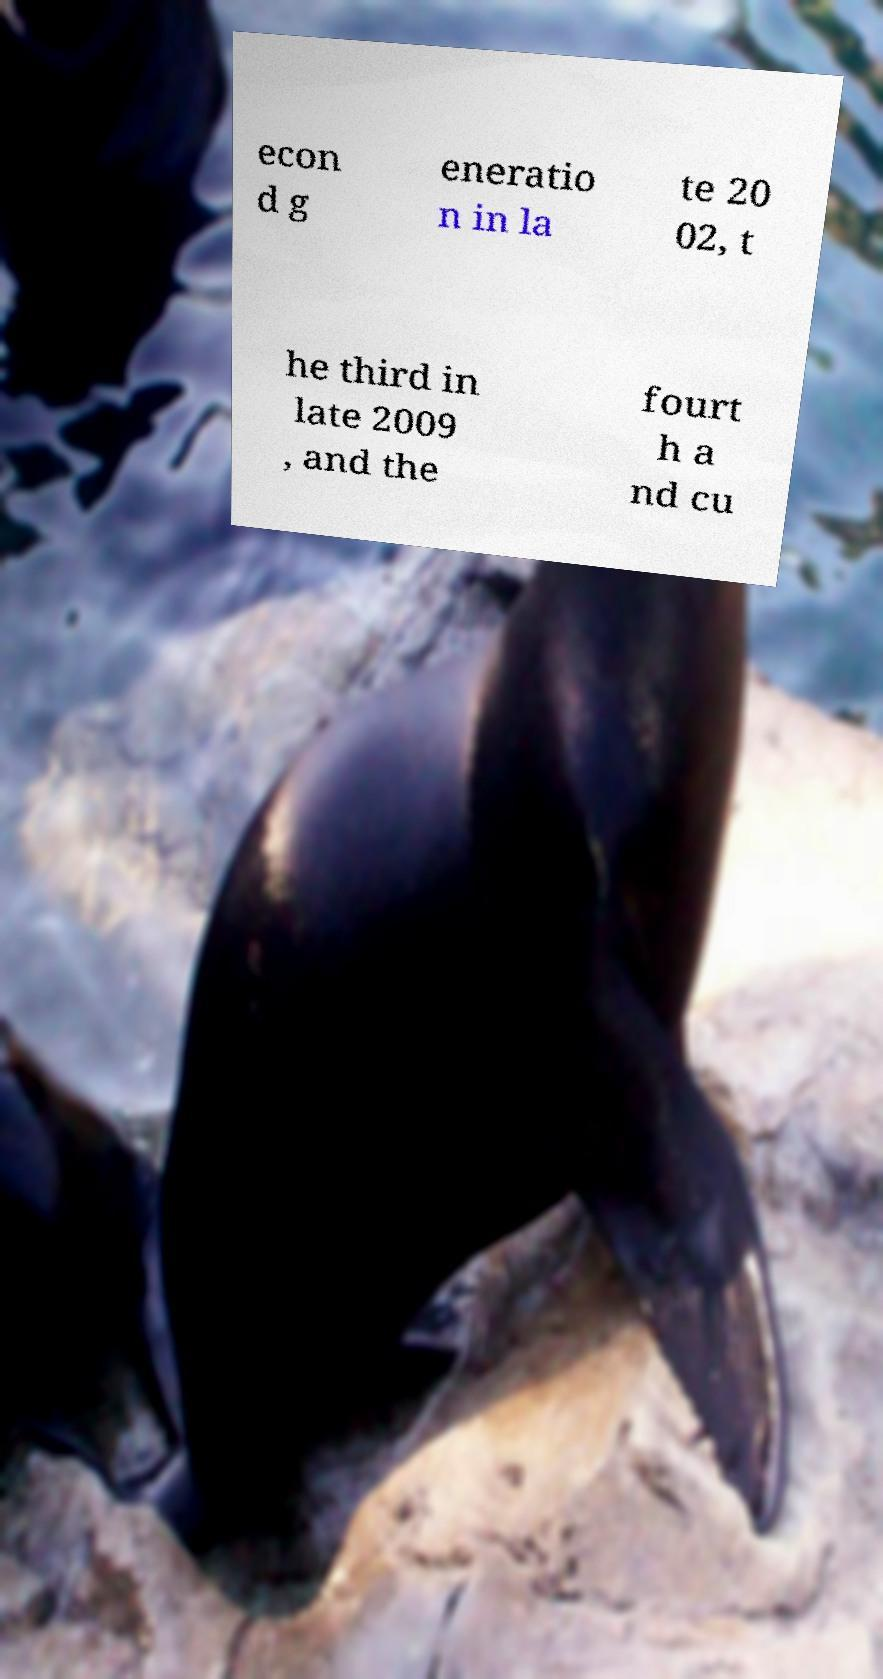Can you accurately transcribe the text from the provided image for me? econ d g eneratio n in la te 20 02, t he third in late 2009 , and the fourt h a nd cu 